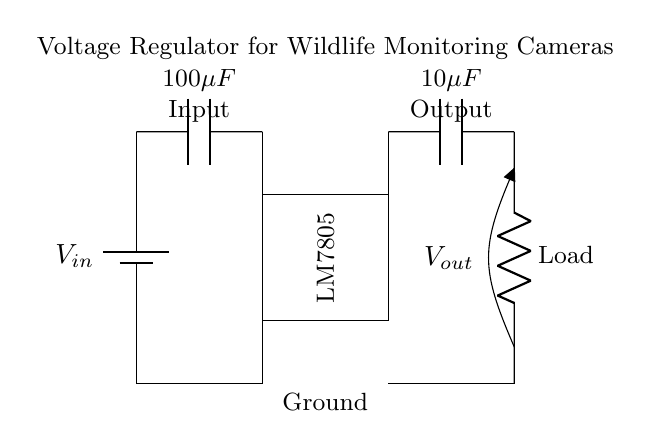What type of voltage regulator is used in this circuit? The circuit diagram shows an LM7805 voltage regulator, which is indicated by the label inside the rectangle representing the IC.
Answer: LM7805 What is the input capacitance value? The circuit diagram specifies an input capacitor labeled with a value of one hundred microfarads, which is shown next to the capacitor symbol.
Answer: 100 microfarads What is the purpose of the output capacitor? The output capacitor is used to stabilize the output voltage by filtering any unwanted fluctuations, as indicated by its position in relation to the load.
Answer: Stabilization What does Vout represent in this circuit? Vout in the circuit represents the output voltage delivered to the load, which is located at the end of the output branch and measured across the output capacitor.
Answer: Output Voltage How many total resistive loads are indicated in this circuit? The circuit shows a single load resistor connected to the output capacitor, clearly labeled as 'Load'.
Answer: One What is the output voltage rating of the LM7805? The LM7805 voltage regulator is designed to provide an output voltage of five volts as indicated by the name, which suggests its regulation capability.
Answer: 5 volts How does the input voltage connect to the voltage regulator? The input voltage, denoted by Vin, connects directly to the voltage regulator IC, as marked by the line leading to the regulator from the battery symbol.
Answer: Directly connected 